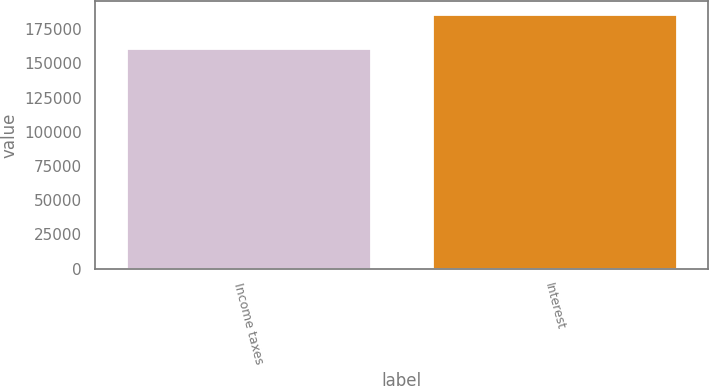<chart> <loc_0><loc_0><loc_500><loc_500><bar_chart><fcel>Income taxes<fcel>Interest<nl><fcel>161671<fcel>186280<nl></chart> 